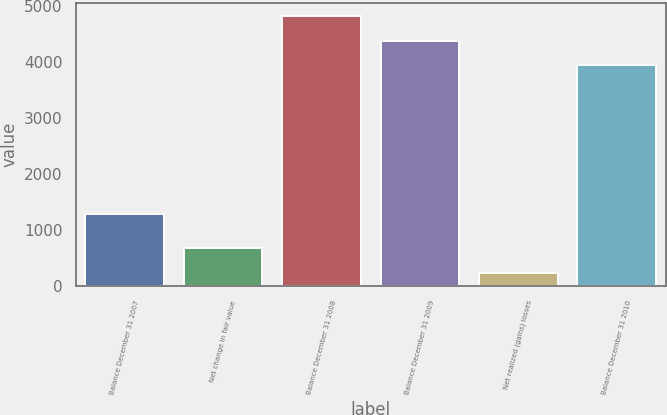<chart> <loc_0><loc_0><loc_500><loc_500><bar_chart><fcel>Balance December 31 2007<fcel>Net change in fair value<fcel>Balance December 31 2008<fcel>Balance December 31 2009<fcel>Net realized (gains) losses<fcel>Balance December 31 2010<nl><fcel>1301<fcel>688.3<fcel>4825.6<fcel>4386.3<fcel>249<fcel>3947<nl></chart> 